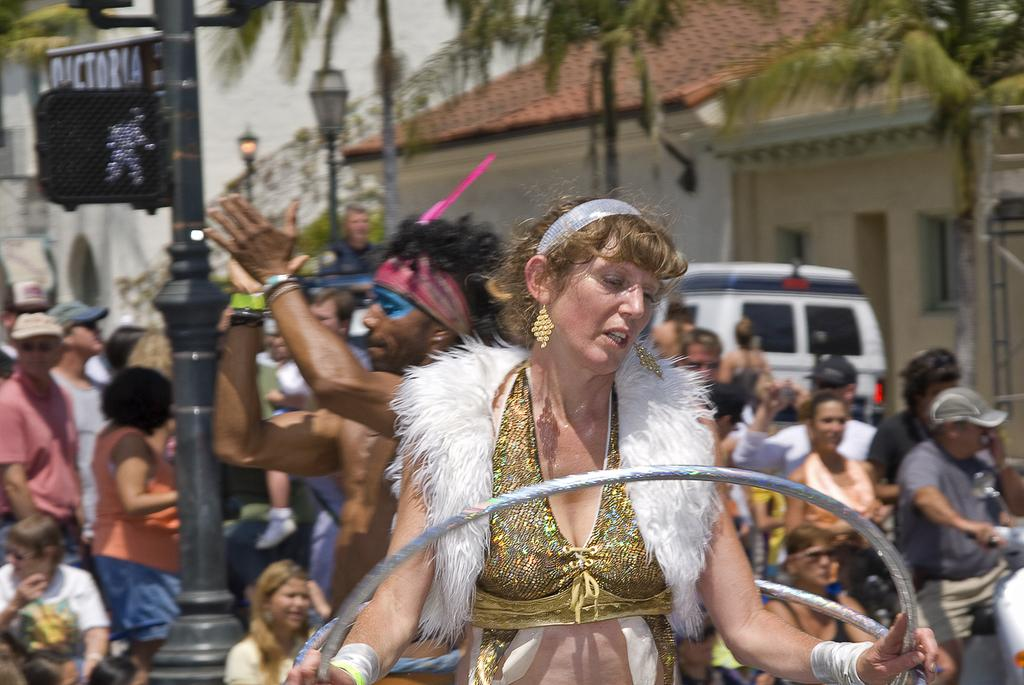Who is the main subject in the image? There is a woman in the image. What is a notable feature of the woman's appearance? The woman has golden hair. What is the woman doing in the image? The woman is standing with a hula hoop ring. What can be seen in the background of the image? There are many people in the background of the image, and they are on the street. What time of day is the woman's mom putting her to sleep in the image? There is no mention of a mom or sleep in the image; it features a woman with a hula hoop ring and many people in the background. 